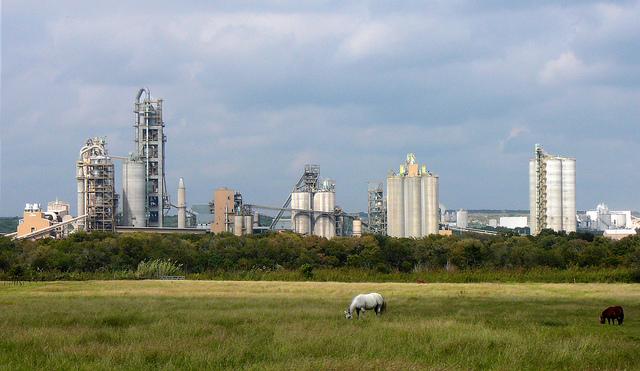Is that a normal setting to find a horse?
Short answer required. Yes. Are these office buildings?
Give a very brief answer. No. What do you call the towered building?
Keep it brief. Silo. Are these animals near an industrial park?
Concise answer only. Yes. 